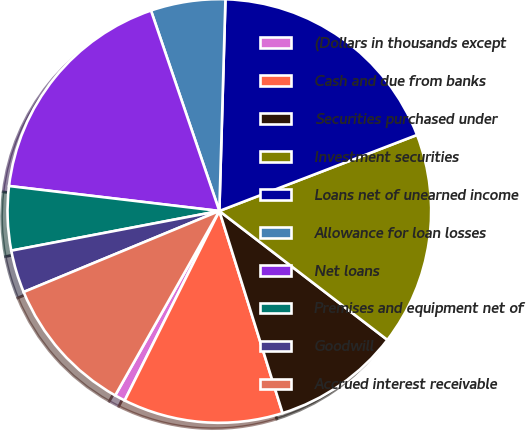Convert chart to OTSL. <chart><loc_0><loc_0><loc_500><loc_500><pie_chart><fcel>(Dollars in thousands except<fcel>Cash and due from banks<fcel>Securities purchased under<fcel>Investment securities<fcel>Loans net of unearned income<fcel>Allowance for loan losses<fcel>Net loans<fcel>Premises and equipment net of<fcel>Goodwill<fcel>Accrued interest receivable<nl><fcel>0.81%<fcel>12.2%<fcel>9.76%<fcel>16.26%<fcel>18.7%<fcel>5.69%<fcel>17.89%<fcel>4.88%<fcel>3.25%<fcel>10.57%<nl></chart> 